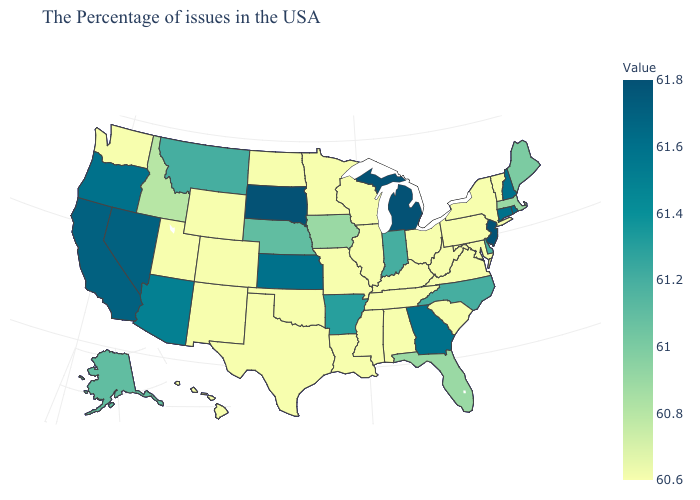Among the states that border Colorado , does Wyoming have the lowest value?
Concise answer only. Yes. Does Pennsylvania have the highest value in the USA?
Answer briefly. No. 